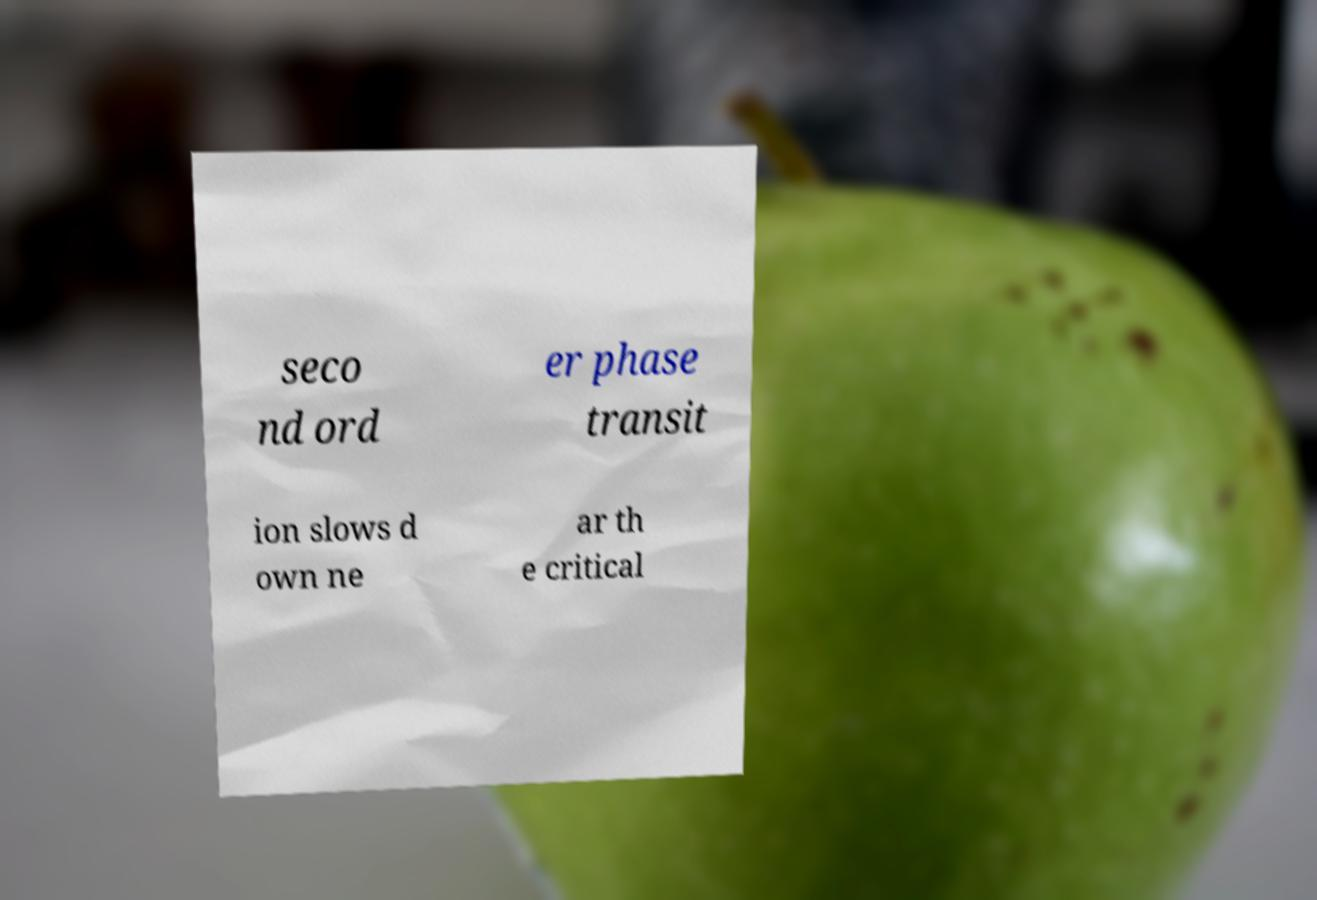For documentation purposes, I need the text within this image transcribed. Could you provide that? seco nd ord er phase transit ion slows d own ne ar th e critical 